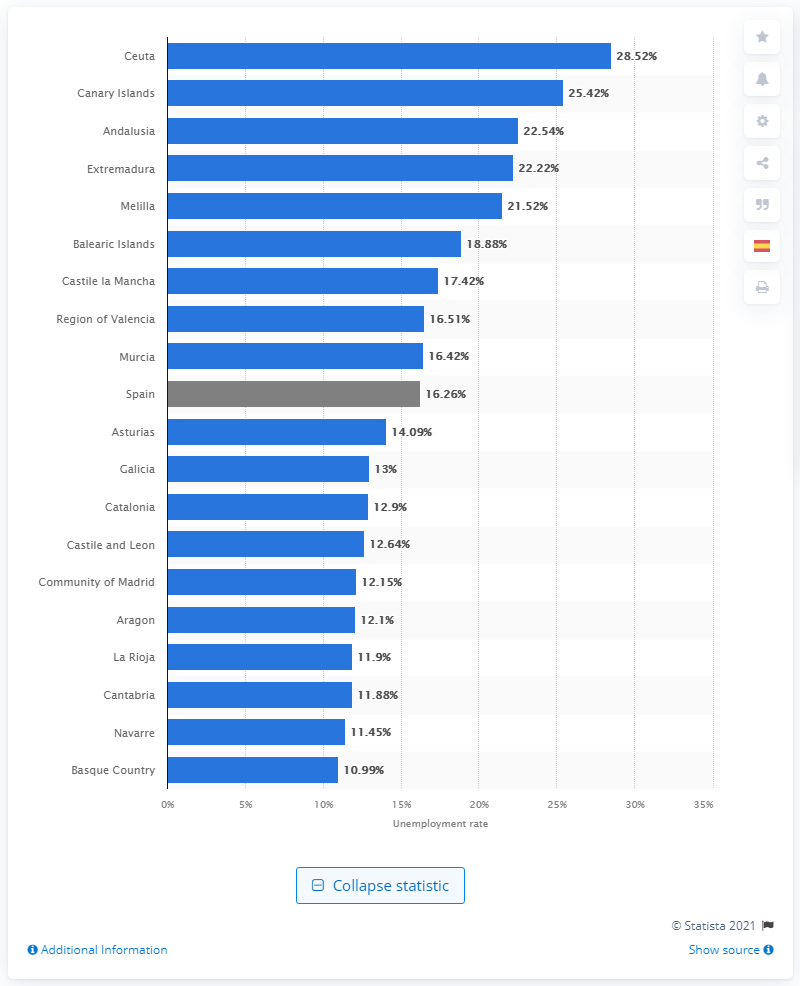Which regions have an unemployment rate under 13%? According to the image, the regions of Catalonia, Castile and Leon, Community of Madrid, Aragon, La Rioja, Cantabria, Navarre, and the Basque Country all have an unemployment rate under 13%. 